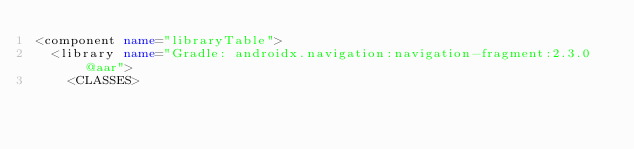<code> <loc_0><loc_0><loc_500><loc_500><_XML_><component name="libraryTable">
  <library name="Gradle: androidx.navigation:navigation-fragment:2.3.0@aar">
    <CLASSES></code> 